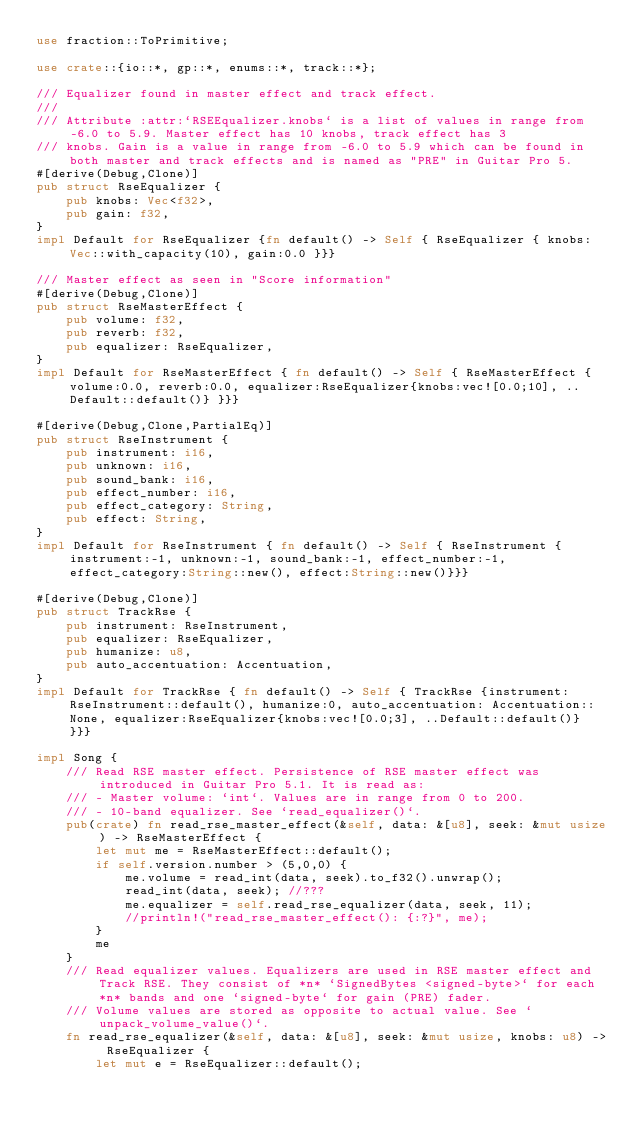Convert code to text. <code><loc_0><loc_0><loc_500><loc_500><_Rust_>use fraction::ToPrimitive;

use crate::{io::*, gp::*, enums::*, track::*};

/// Equalizer found in master effect and track effect.
/// 
/// Attribute :attr:`RSEEqualizer.knobs` is a list of values in range from -6.0 to 5.9. Master effect has 10 knobs, track effect has 3
/// knobs. Gain is a value in range from -6.0 to 5.9 which can be found in both master and track effects and is named as "PRE" in Guitar Pro 5.
#[derive(Debug,Clone)]
pub struct RseEqualizer {
    pub knobs: Vec<f32>,
    pub gain: f32,
}
impl Default for RseEqualizer {fn default() -> Self { RseEqualizer { knobs: Vec::with_capacity(10), gain:0.0 }}}

/// Master effect as seen in "Score information"
#[derive(Debug,Clone)]
pub struct RseMasterEffect {
    pub volume: f32,
    pub reverb: f32,
    pub equalizer: RseEqualizer,
}
impl Default for RseMasterEffect { fn default() -> Self { RseMasterEffect {volume:0.0, reverb:0.0, equalizer:RseEqualizer{knobs:vec![0.0;10], ..Default::default()} }}}

#[derive(Debug,Clone,PartialEq)]
pub struct RseInstrument {
    pub instrument: i16,
    pub unknown: i16,
    pub sound_bank: i16,
    pub effect_number: i16,
    pub effect_category: String,
    pub effect: String,
}
impl Default for RseInstrument { fn default() -> Self { RseInstrument { instrument:-1, unknown:-1, sound_bank:-1, effect_number:-1, effect_category:String::new(), effect:String::new()}}}

#[derive(Debug,Clone)]
pub struct TrackRse {
    pub instrument: RseInstrument,
    pub equalizer: RseEqualizer,
    pub humanize: u8,
    pub auto_accentuation: Accentuation,
}
impl Default for TrackRse { fn default() -> Self { TrackRse {instrument:RseInstrument::default(), humanize:0, auto_accentuation: Accentuation::None, equalizer:RseEqualizer{knobs:vec![0.0;3], ..Default::default()} }}}

impl Song {
    /// Read RSE master effect. Persistence of RSE master effect was introduced in Guitar Pro 5.1. It is read as:
    /// - Master volume: `int`. Values are in range from 0 to 200.
    /// - 10-band equalizer. See `read_equalizer()`.
    pub(crate) fn read_rse_master_effect(&self, data: &[u8], seek: &mut usize) -> RseMasterEffect {
        let mut me = RseMasterEffect::default();
        if self.version.number > (5,0,0) {
            me.volume = read_int(data, seek).to_f32().unwrap();
            read_int(data, seek); //???
            me.equalizer = self.read_rse_equalizer(data, seek, 11);
            //println!("read_rse_master_effect(): {:?}", me);
        }
        me
    }
    /// Read equalizer values. Equalizers are used in RSE master effect and Track RSE. They consist of *n* `SignedBytes <signed-byte>` for each *n* bands and one `signed-byte` for gain (PRE) fader.
    /// Volume values are stored as opposite to actual value. See `unpack_volume_value()`.
    fn read_rse_equalizer(&self, data: &[u8], seek: &mut usize, knobs: u8) -> RseEqualizer {
        let mut e = RseEqualizer::default();</code> 